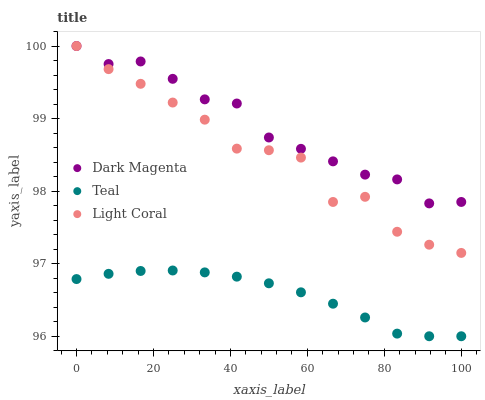Does Teal have the minimum area under the curve?
Answer yes or no. Yes. Does Dark Magenta have the maximum area under the curve?
Answer yes or no. Yes. Does Dark Magenta have the minimum area under the curve?
Answer yes or no. No. Does Teal have the maximum area under the curve?
Answer yes or no. No. Is Teal the smoothest?
Answer yes or no. Yes. Is Light Coral the roughest?
Answer yes or no. Yes. Is Dark Magenta the smoothest?
Answer yes or no. No. Is Dark Magenta the roughest?
Answer yes or no. No. Does Teal have the lowest value?
Answer yes or no. Yes. Does Dark Magenta have the lowest value?
Answer yes or no. No. Does Dark Magenta have the highest value?
Answer yes or no. Yes. Does Teal have the highest value?
Answer yes or no. No. Is Teal less than Light Coral?
Answer yes or no. Yes. Is Dark Magenta greater than Teal?
Answer yes or no. Yes. Does Dark Magenta intersect Light Coral?
Answer yes or no. Yes. Is Dark Magenta less than Light Coral?
Answer yes or no. No. Is Dark Magenta greater than Light Coral?
Answer yes or no. No. Does Teal intersect Light Coral?
Answer yes or no. No. 